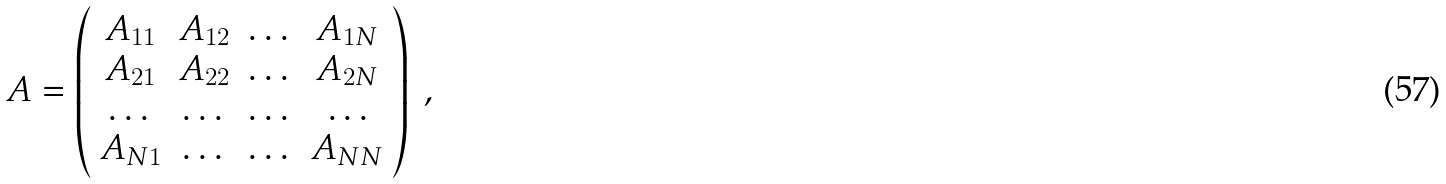Convert formula to latex. <formula><loc_0><loc_0><loc_500><loc_500>A = \left ( \begin{array} { c c c c } A _ { 1 1 } & A _ { 1 2 } & \dots & A _ { 1 N } \\ A _ { 2 1 } & A _ { 2 2 } & \dots & A _ { 2 N } \\ \dots & \dots & \dots & \dots \\ A _ { N 1 } & \dots & \dots & A _ { N N } \\ \end{array} \right ) \ ,</formula> 